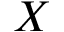Convert formula to latex. <formula><loc_0><loc_0><loc_500><loc_500>X</formula> 